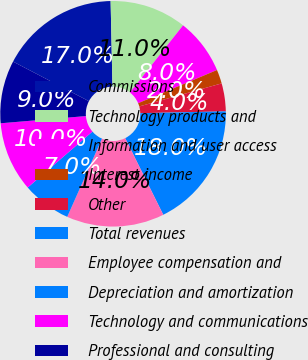Convert chart to OTSL. <chart><loc_0><loc_0><loc_500><loc_500><pie_chart><fcel>Commissions<fcel>Technology products and<fcel>Information and user access<fcel>Interest income<fcel>Other<fcel>Total revenues<fcel>Employee compensation and<fcel>Depreciation and amortization<fcel>Technology and communications<fcel>Professional and consulting<nl><fcel>17.0%<fcel>11.0%<fcel>8.0%<fcel>2.0%<fcel>4.0%<fcel>18.0%<fcel>14.0%<fcel>7.0%<fcel>10.0%<fcel>9.0%<nl></chart> 